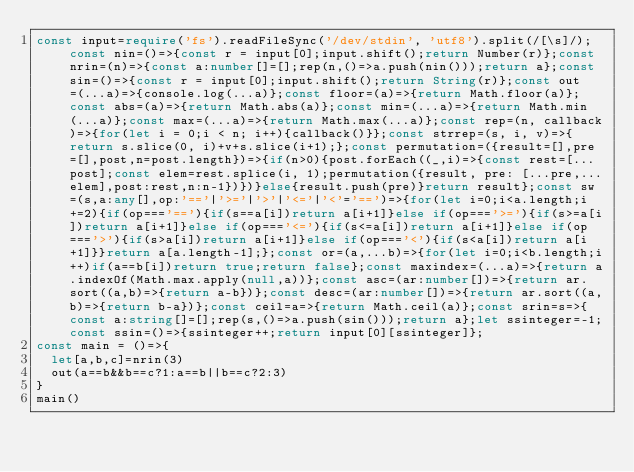Convert code to text. <code><loc_0><loc_0><loc_500><loc_500><_TypeScript_>const input=require('fs').readFileSync('/dev/stdin', 'utf8').split(/[\s]/);const nin=()=>{const r = input[0];input.shift();return Number(r)};const nrin=(n)=>{const a:number[]=[];rep(n,()=>a.push(nin()));return a};const sin=()=>{const r = input[0];input.shift();return String(r)};const out=(...a)=>{console.log(...a)};const floor=(a)=>{return Math.floor(a)};const abs=(a)=>{return Math.abs(a)};const min=(...a)=>{return Math.min(...a)};const max=(...a)=>{return Math.max(...a)};const rep=(n, callback)=>{for(let i = 0;i < n; i++){callback()}};const strrep=(s, i, v)=>{return s.slice(0, i)+v+s.slice(i+1);};const permutation=({result=[],pre=[],post,n=post.length})=>{if(n>0){post.forEach((_,i)=>{const rest=[...post];const elem=rest.splice(i, 1);permutation({result, pre: [...pre,...elem],post:rest,n:n-1})})}else{result.push(pre)}return result};const sw=(s,a:any[],op:'=='|'>='|'>'|'<='|'<'='==')=>{for(let i=0;i<a.length;i+=2){if(op==='=='){if(s==a[i])return a[i+1]}else if(op==='>='){if(s>=a[i])return a[i+1]}else if(op==='<='){if(s<=a[i])return a[i+1]}else if(op==='>'){if(s>a[i])return a[i+1]}else if(op==='<'){if(s<a[i])return a[i+1]}}return a[a.length-1];};const or=(a,...b)=>{for(let i=0;i<b.length;i++)if(a==b[i])return true;return false};const maxindex=(...a)=>{return a.indexOf(Math.max.apply(null,a))};const asc=(ar:number[])=>{return ar.sort((a,b)=>{return a-b})};const desc=(ar:number[])=>{return ar.sort((a,b)=>{return b-a})};const ceil=a=>{return Math.ceil(a)};const srin=s=>{const a:string[]=[];rep(s,()=>a.push(sin()));return a};let ssinteger=-1;const ssin=()=>{ssinteger++;return input[0][ssinteger]};
const main = ()=>{
  let[a,b,c]=nrin(3)
  out(a==b&&b==c?1:a==b||b==c?2:3)
}
main()</code> 